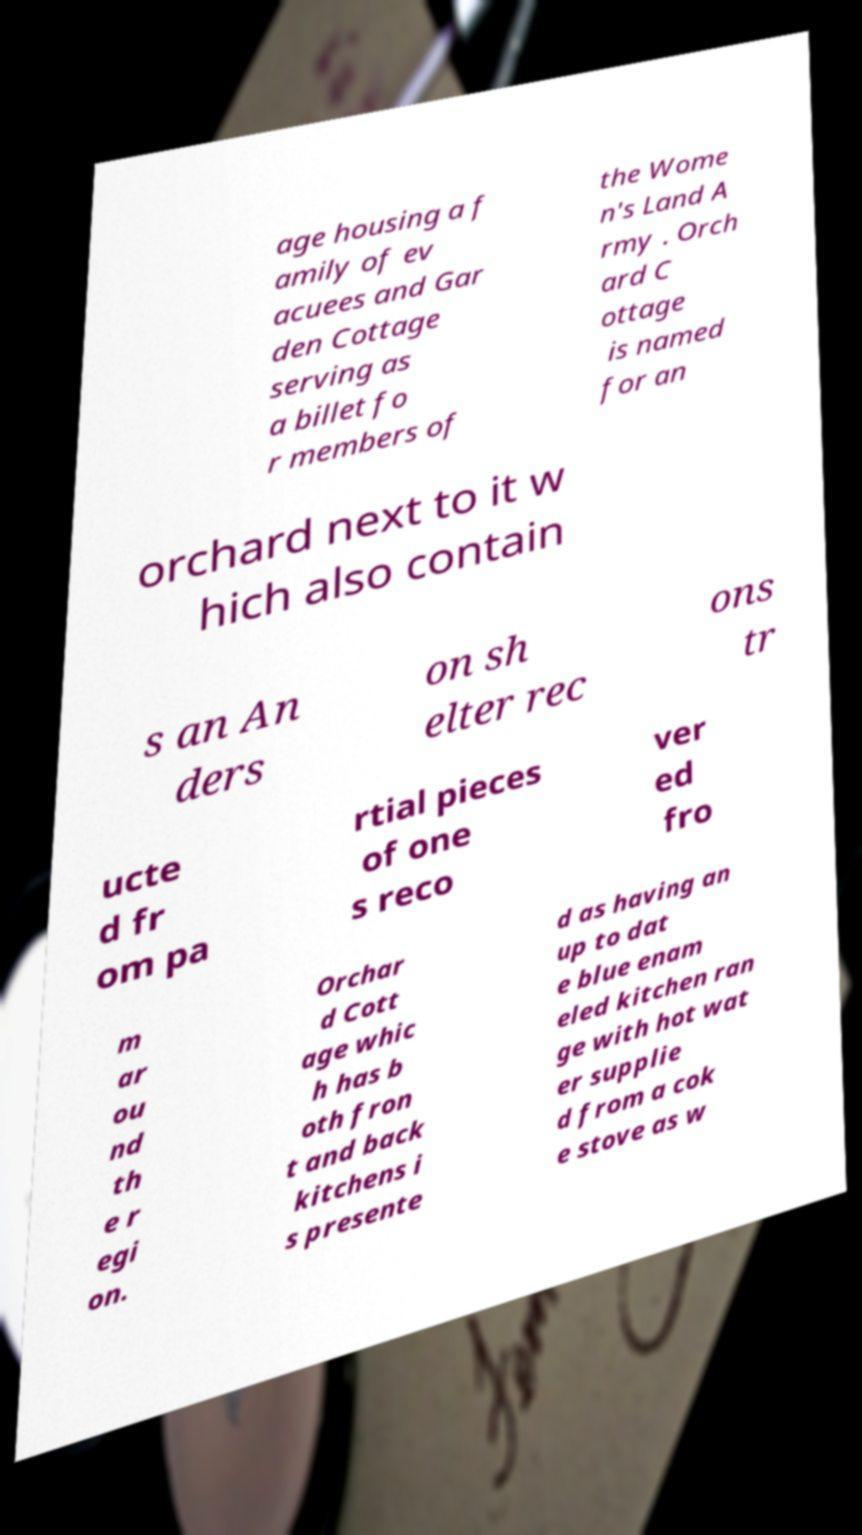What messages or text are displayed in this image? I need them in a readable, typed format. age housing a f amily of ev acuees and Gar den Cottage serving as a billet fo r members of the Wome n's Land A rmy . Orch ard C ottage is named for an orchard next to it w hich also contain s an An ders on sh elter rec ons tr ucte d fr om pa rtial pieces of one s reco ver ed fro m ar ou nd th e r egi on. Orchar d Cott age whic h has b oth fron t and back kitchens i s presente d as having an up to dat e blue enam eled kitchen ran ge with hot wat er supplie d from a cok e stove as w 